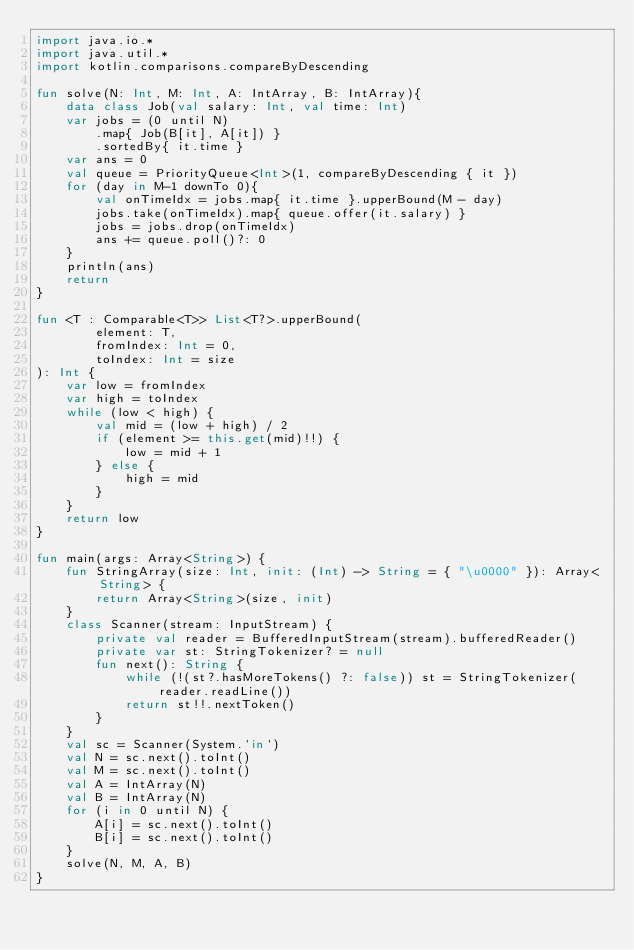<code> <loc_0><loc_0><loc_500><loc_500><_Kotlin_>import java.io.*
import java.util.*
import kotlin.comparisons.compareByDescending

fun solve(N: Int, M: Int, A: IntArray, B: IntArray){
    data class Job(val salary: Int, val time: Int)
    var jobs = (0 until N)
        .map{ Job(B[it], A[it]) }
        .sortedBy{ it.time }
    var ans = 0
    val queue = PriorityQueue<Int>(1, compareByDescending { it })
    for (day in M-1 downTo 0){
        val onTimeIdx = jobs.map{ it.time }.upperBound(M - day)
        jobs.take(onTimeIdx).map{ queue.offer(it.salary) }
        jobs = jobs.drop(onTimeIdx)
        ans += queue.poll()?: 0
    }
    println(ans)
    return
}

fun <T : Comparable<T>> List<T?>.upperBound(
        element: T,
        fromIndex: Int = 0,
        toIndex: Int = size
): Int {
    var low = fromIndex
    var high = toIndex
    while (low < high) {
        val mid = (low + high) / 2
        if (element >= this.get(mid)!!) {
            low = mid + 1
        } else {
            high = mid
        }
    }
    return low
}

fun main(args: Array<String>) {
    fun StringArray(size: Int, init: (Int) -> String = { "\u0000" }): Array<String> {
        return Array<String>(size, init)
    }
    class Scanner(stream: InputStream) {
        private val reader = BufferedInputStream(stream).bufferedReader()
        private var st: StringTokenizer? = null
        fun next(): String {
            while (!(st?.hasMoreTokens() ?: false)) st = StringTokenizer(reader.readLine())
            return st!!.nextToken()
        }
    }
    val sc = Scanner(System.`in`)
    val N = sc.next().toInt()
    val M = sc.next().toInt()
    val A = IntArray(N)
    val B = IntArray(N)
    for (i in 0 until N) {
        A[i] = sc.next().toInt()
        B[i] = sc.next().toInt()
    }
    solve(N, M, A, B)
}
</code> 